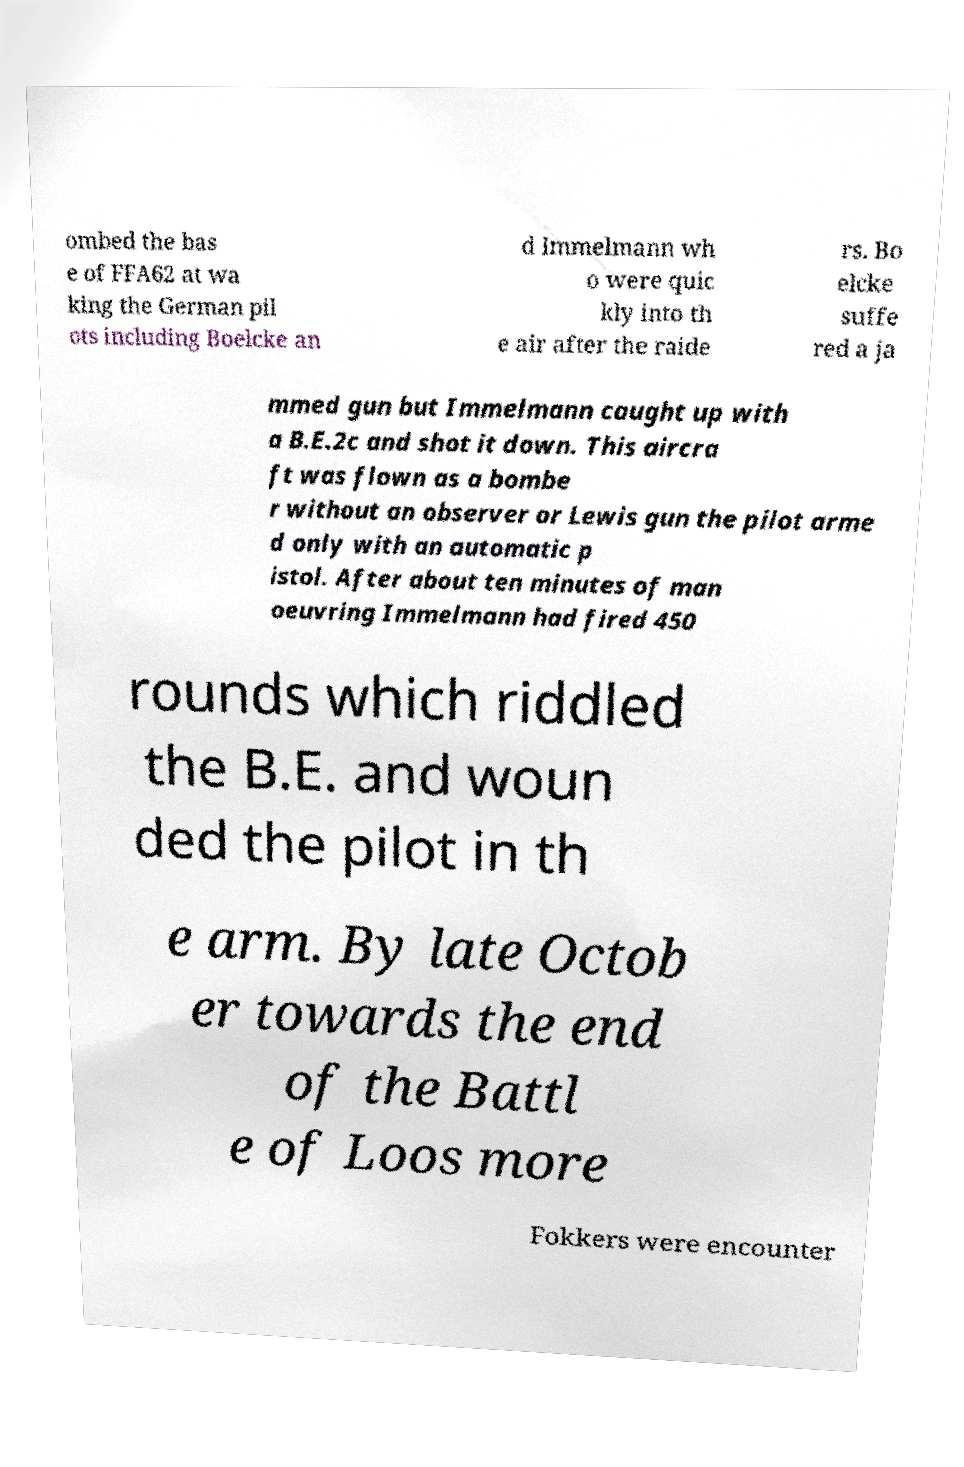Please read and relay the text visible in this image. What does it say? ombed the bas e of FFA62 at wa king the German pil ots including Boelcke an d Immelmann wh o were quic kly into th e air after the raide rs. Bo elcke suffe red a ja mmed gun but Immelmann caught up with a B.E.2c and shot it down. This aircra ft was flown as a bombe r without an observer or Lewis gun the pilot arme d only with an automatic p istol. After about ten minutes of man oeuvring Immelmann had fired 450 rounds which riddled the B.E. and woun ded the pilot in th e arm. By late Octob er towards the end of the Battl e of Loos more Fokkers were encounter 